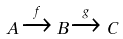<formula> <loc_0><loc_0><loc_500><loc_500>A \xrightarrow { f } B \xrightarrow { g } C</formula> 